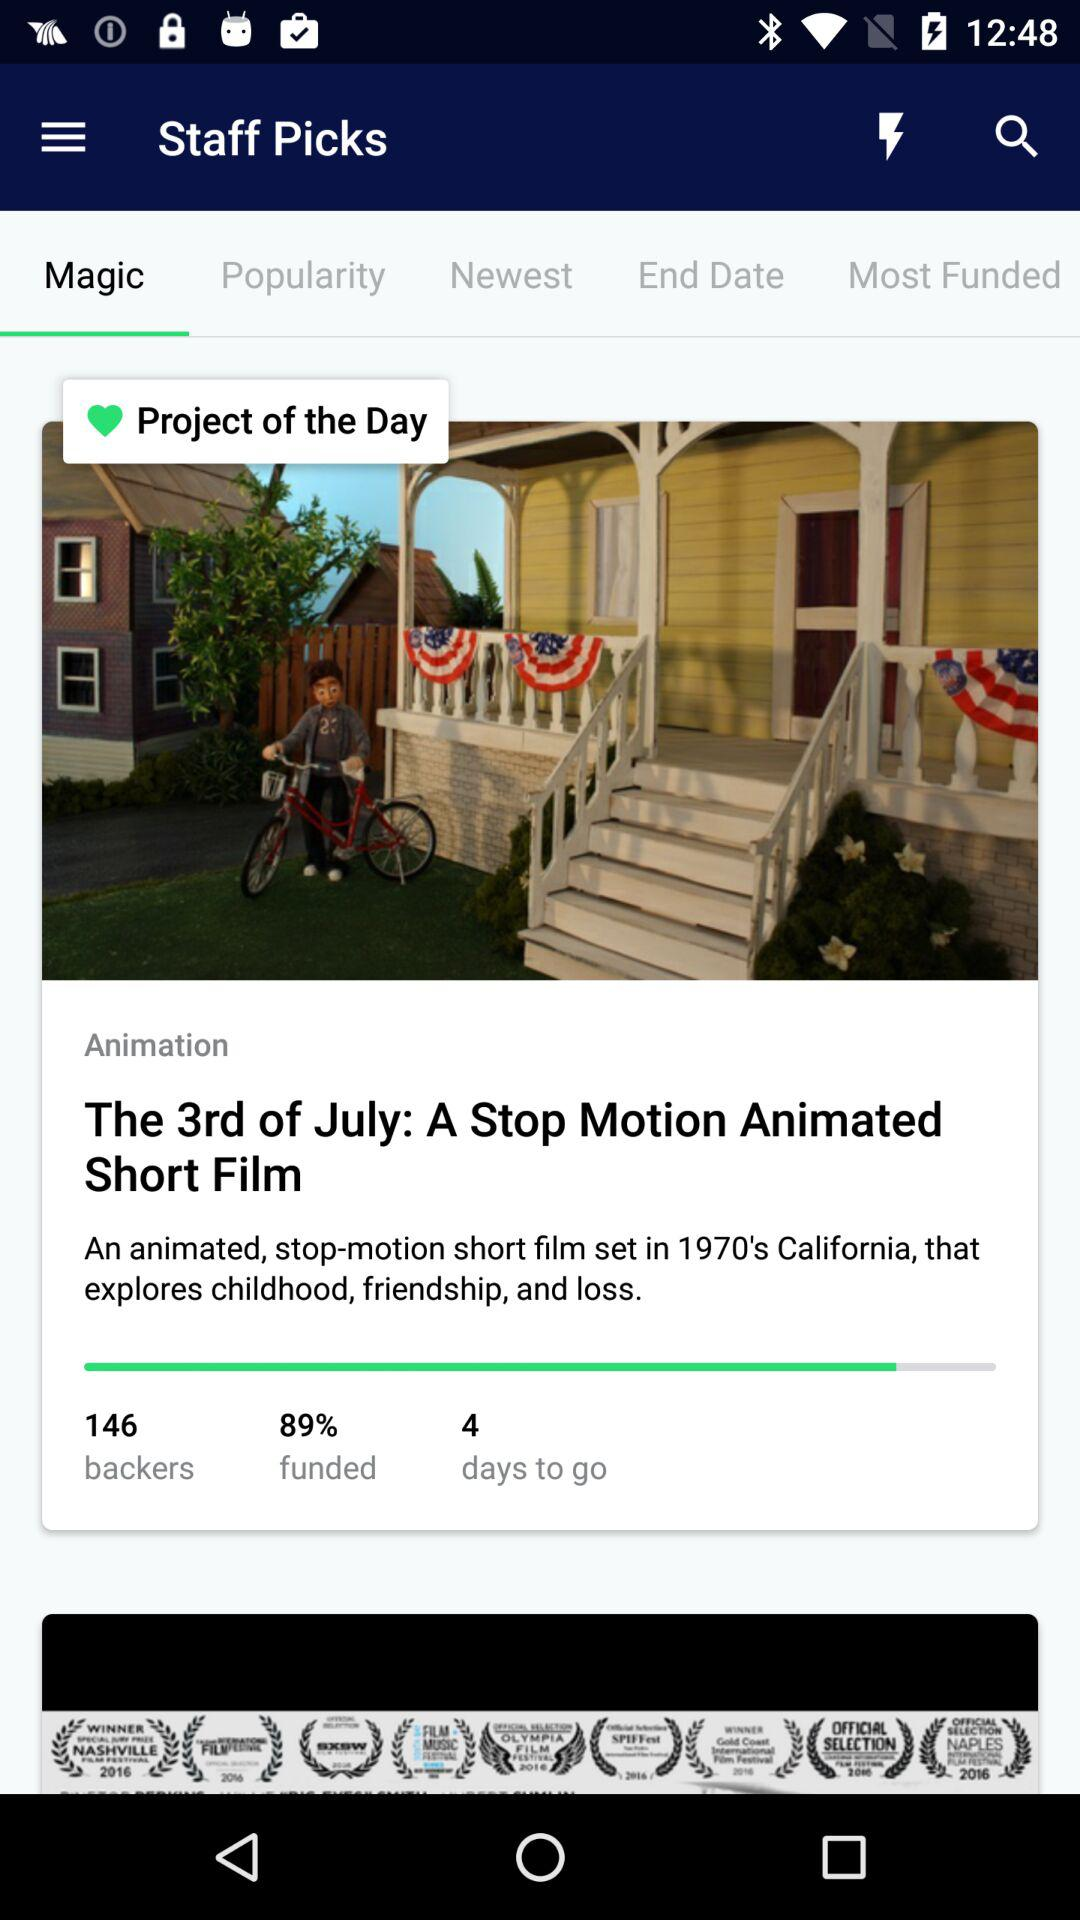What percentage of the film is funded? The funded percentage of the film is 89. 